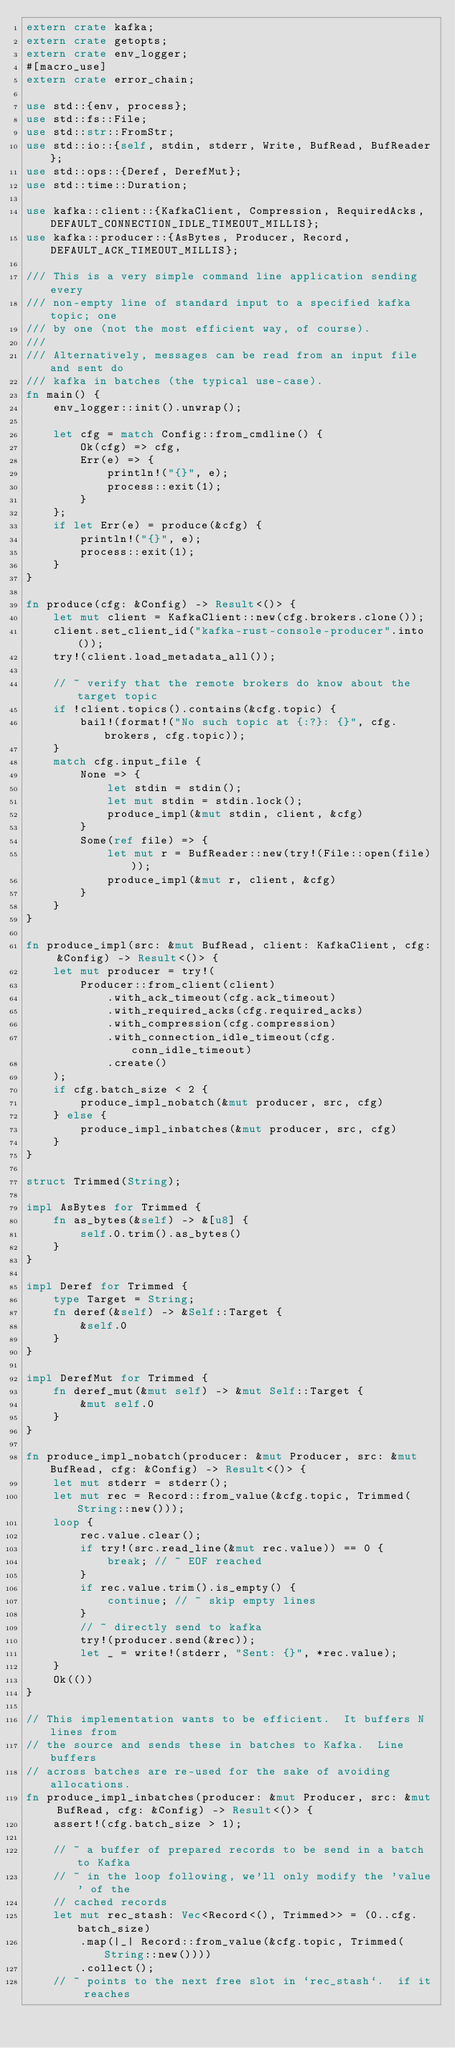<code> <loc_0><loc_0><loc_500><loc_500><_Rust_>extern crate kafka;
extern crate getopts;
extern crate env_logger;
#[macro_use]
extern crate error_chain;

use std::{env, process};
use std::fs::File;
use std::str::FromStr;
use std::io::{self, stdin, stderr, Write, BufRead, BufReader};
use std::ops::{Deref, DerefMut};
use std::time::Duration;

use kafka::client::{KafkaClient, Compression, RequiredAcks, DEFAULT_CONNECTION_IDLE_TIMEOUT_MILLIS};
use kafka::producer::{AsBytes, Producer, Record, DEFAULT_ACK_TIMEOUT_MILLIS};

/// This is a very simple command line application sending every
/// non-empty line of standard input to a specified kafka topic; one
/// by one (not the most efficient way, of course).
///
/// Alternatively, messages can be read from an input file and sent do
/// kafka in batches (the typical use-case).
fn main() {
    env_logger::init().unwrap();

    let cfg = match Config::from_cmdline() {
        Ok(cfg) => cfg,
        Err(e) => {
            println!("{}", e);
            process::exit(1);
        }
    };
    if let Err(e) = produce(&cfg) {
        println!("{}", e);
        process::exit(1);
    }
}

fn produce(cfg: &Config) -> Result<()> {
    let mut client = KafkaClient::new(cfg.brokers.clone());
    client.set_client_id("kafka-rust-console-producer".into());
    try!(client.load_metadata_all());

    // ~ verify that the remote brokers do know about the target topic
    if !client.topics().contains(&cfg.topic) {
        bail!(format!("No such topic at {:?}: {}", cfg.brokers, cfg.topic));
    }
    match cfg.input_file {
        None => {
            let stdin = stdin();
            let mut stdin = stdin.lock();
            produce_impl(&mut stdin, client, &cfg)
        }
        Some(ref file) => {
            let mut r = BufReader::new(try!(File::open(file)));
            produce_impl(&mut r, client, &cfg)
        }
    }
}

fn produce_impl(src: &mut BufRead, client: KafkaClient, cfg: &Config) -> Result<()> {
    let mut producer = try!(
        Producer::from_client(client)
            .with_ack_timeout(cfg.ack_timeout)
            .with_required_acks(cfg.required_acks)
            .with_compression(cfg.compression)
            .with_connection_idle_timeout(cfg.conn_idle_timeout)
            .create()
    );
    if cfg.batch_size < 2 {
        produce_impl_nobatch(&mut producer, src, cfg)
    } else {
        produce_impl_inbatches(&mut producer, src, cfg)
    }
}

struct Trimmed(String);

impl AsBytes for Trimmed {
    fn as_bytes(&self) -> &[u8] {
        self.0.trim().as_bytes()
    }
}

impl Deref for Trimmed {
    type Target = String;
    fn deref(&self) -> &Self::Target {
        &self.0
    }
}

impl DerefMut for Trimmed {
    fn deref_mut(&mut self) -> &mut Self::Target {
        &mut self.0
    }
}

fn produce_impl_nobatch(producer: &mut Producer, src: &mut BufRead, cfg: &Config) -> Result<()> {
    let mut stderr = stderr();
    let mut rec = Record::from_value(&cfg.topic, Trimmed(String::new()));
    loop {
        rec.value.clear();
        if try!(src.read_line(&mut rec.value)) == 0 {
            break; // ~ EOF reached
        }
        if rec.value.trim().is_empty() {
            continue; // ~ skip empty lines
        }
        // ~ directly send to kafka
        try!(producer.send(&rec));
        let _ = write!(stderr, "Sent: {}", *rec.value);
    }
    Ok(())
}

// This implementation wants to be efficient.  It buffers N lines from
// the source and sends these in batches to Kafka.  Line buffers
// across batches are re-used for the sake of avoiding allocations.
fn produce_impl_inbatches(producer: &mut Producer, src: &mut BufRead, cfg: &Config) -> Result<()> {
    assert!(cfg.batch_size > 1);

    // ~ a buffer of prepared records to be send in a batch to Kafka
    // ~ in the loop following, we'll only modify the 'value' of the
    // cached records
    let mut rec_stash: Vec<Record<(), Trimmed>> = (0..cfg.batch_size)
        .map(|_| Record::from_value(&cfg.topic, Trimmed(String::new())))
        .collect();
    // ~ points to the next free slot in `rec_stash`.  if it reaches</code> 